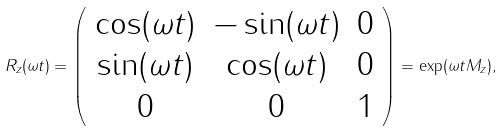<formula> <loc_0><loc_0><loc_500><loc_500>R _ { z } ( \omega t ) = \left ( \begin{array} { c c c } \cos ( \omega t ) & - \sin ( \omega t ) & 0 \\ \sin ( \omega t ) & \cos ( \omega t ) & 0 \\ 0 & 0 & 1 \end{array} \right ) = \exp ( \omega t M _ { z } ) ,</formula> 